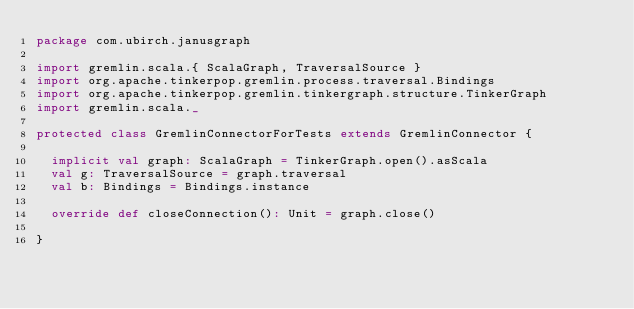<code> <loc_0><loc_0><loc_500><loc_500><_Scala_>package com.ubirch.janusgraph

import gremlin.scala.{ ScalaGraph, TraversalSource }
import org.apache.tinkerpop.gremlin.process.traversal.Bindings
import org.apache.tinkerpop.gremlin.tinkergraph.structure.TinkerGraph
import gremlin.scala._

protected class GremlinConnectorForTests extends GremlinConnector {

  implicit val graph: ScalaGraph = TinkerGraph.open().asScala
  val g: TraversalSource = graph.traversal
  val b: Bindings = Bindings.instance

  override def closeConnection(): Unit = graph.close()

}
</code> 